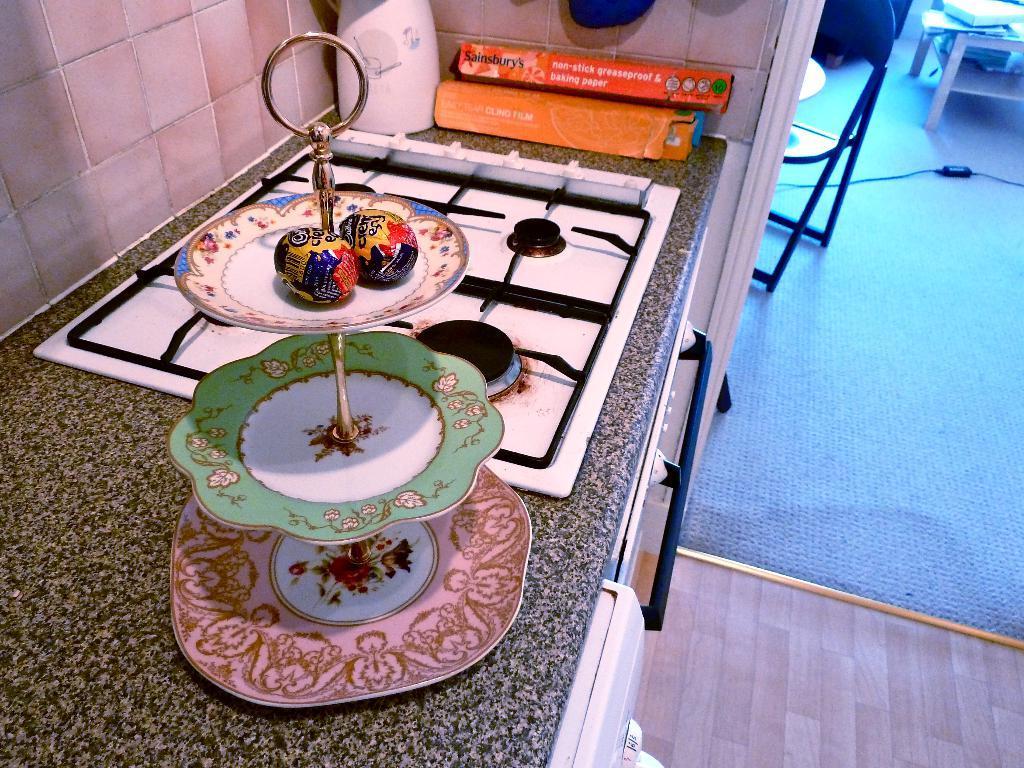How would you summarize this image in a sentence or two? In this image i can see a object which is placed on the table. 